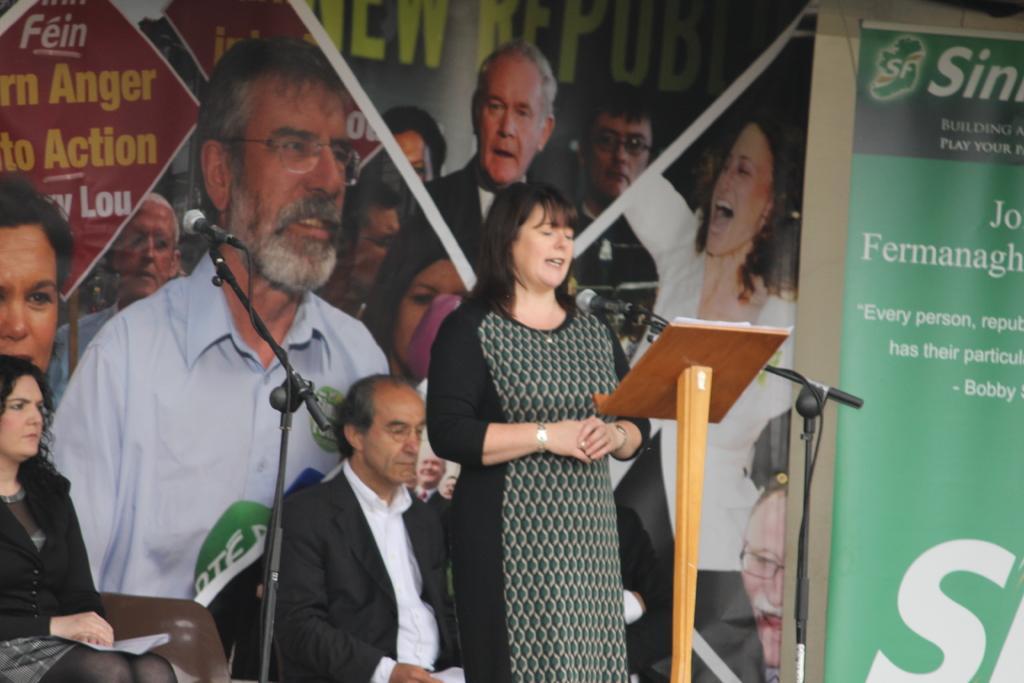How would you summarize this image in a sentence or two? In this image we can see the person standing and talking into a microphone. In front of her there is a podium. At the back there are people sitting on the chair and holding a paper. And there are banners with text and images attached to the wall. 